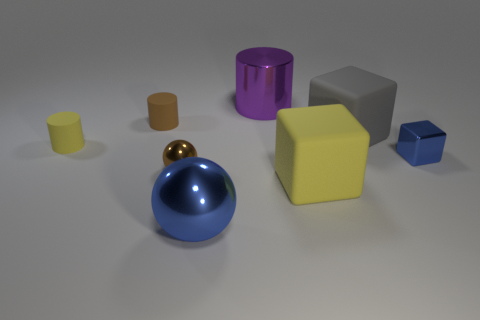Subtract all purple metal cylinders. How many cylinders are left? 2 Add 1 large yellow balls. How many objects exist? 9 Subtract all yellow cylinders. How many cylinders are left? 2 Subtract 1 spheres. How many spheres are left? 1 Subtract all green shiny things. Subtract all small blue things. How many objects are left? 7 Add 8 brown spheres. How many brown spheres are left? 9 Add 5 small rubber cylinders. How many small rubber cylinders exist? 7 Subtract 0 gray balls. How many objects are left? 8 Subtract all balls. How many objects are left? 6 Subtract all cyan blocks. Subtract all green cylinders. How many blocks are left? 3 